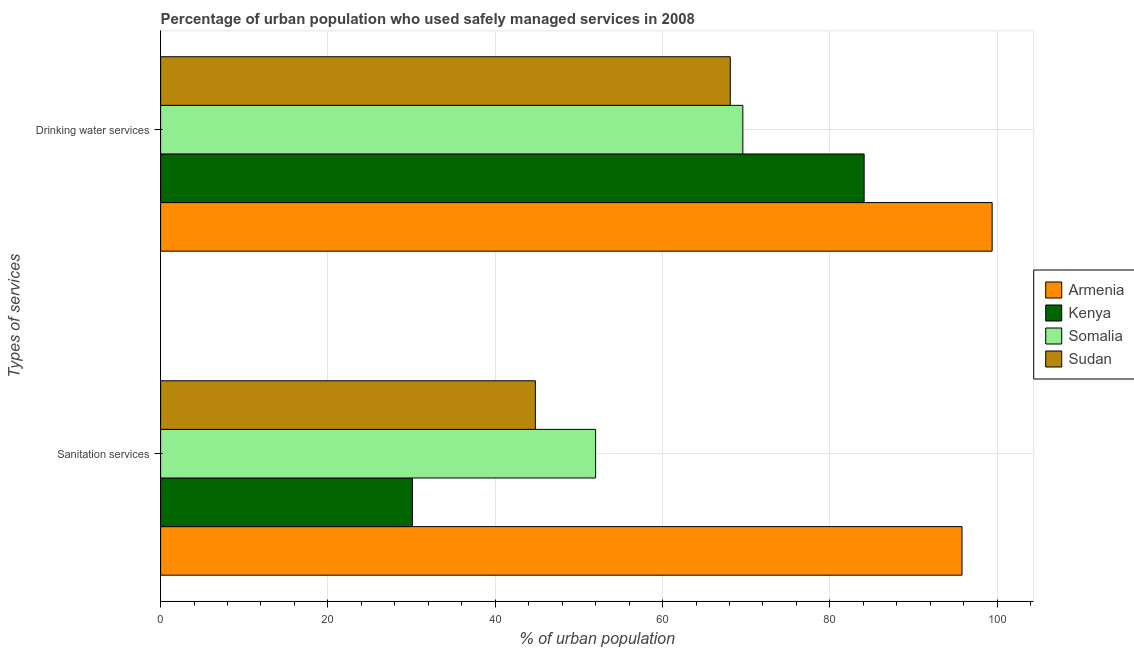How many different coloured bars are there?
Your response must be concise. 4. How many bars are there on the 2nd tick from the top?
Your response must be concise. 4. How many bars are there on the 1st tick from the bottom?
Keep it short and to the point. 4. What is the label of the 1st group of bars from the top?
Offer a terse response. Drinking water services. What is the percentage of urban population who used drinking water services in Sudan?
Make the answer very short. 68.1. Across all countries, what is the maximum percentage of urban population who used drinking water services?
Provide a succinct answer. 99.4. Across all countries, what is the minimum percentage of urban population who used drinking water services?
Provide a succinct answer. 68.1. In which country was the percentage of urban population who used drinking water services maximum?
Your answer should be very brief. Armenia. In which country was the percentage of urban population who used sanitation services minimum?
Make the answer very short. Kenya. What is the total percentage of urban population who used drinking water services in the graph?
Your answer should be compact. 321.2. What is the difference between the percentage of urban population who used sanitation services in Armenia and that in Kenya?
Provide a succinct answer. 65.7. What is the difference between the percentage of urban population who used sanitation services in Kenya and the percentage of urban population who used drinking water services in Sudan?
Ensure brevity in your answer.  -38. What is the average percentage of urban population who used sanitation services per country?
Make the answer very short. 55.67. What is the difference between the percentage of urban population who used drinking water services and percentage of urban population who used sanitation services in Armenia?
Give a very brief answer. 3.6. In how many countries, is the percentage of urban population who used drinking water services greater than 88 %?
Keep it short and to the point. 1. What is the ratio of the percentage of urban population who used drinking water services in Sudan to that in Somalia?
Offer a very short reply. 0.98. In how many countries, is the percentage of urban population who used drinking water services greater than the average percentage of urban population who used drinking water services taken over all countries?
Offer a very short reply. 2. What does the 2nd bar from the top in Drinking water services represents?
Provide a succinct answer. Somalia. What does the 4th bar from the bottom in Drinking water services represents?
Keep it short and to the point. Sudan. How many bars are there?
Provide a succinct answer. 8. What is the difference between two consecutive major ticks on the X-axis?
Your answer should be compact. 20. Are the values on the major ticks of X-axis written in scientific E-notation?
Your answer should be very brief. No. What is the title of the graph?
Your answer should be very brief. Percentage of urban population who used safely managed services in 2008. Does "Qatar" appear as one of the legend labels in the graph?
Keep it short and to the point. No. What is the label or title of the X-axis?
Offer a very short reply. % of urban population. What is the label or title of the Y-axis?
Give a very brief answer. Types of services. What is the % of urban population in Armenia in Sanitation services?
Provide a short and direct response. 95.8. What is the % of urban population of Kenya in Sanitation services?
Your answer should be very brief. 30.1. What is the % of urban population in Sudan in Sanitation services?
Offer a very short reply. 44.8. What is the % of urban population in Armenia in Drinking water services?
Make the answer very short. 99.4. What is the % of urban population in Kenya in Drinking water services?
Provide a succinct answer. 84.1. What is the % of urban population of Somalia in Drinking water services?
Provide a succinct answer. 69.6. What is the % of urban population in Sudan in Drinking water services?
Give a very brief answer. 68.1. Across all Types of services, what is the maximum % of urban population of Armenia?
Provide a short and direct response. 99.4. Across all Types of services, what is the maximum % of urban population in Kenya?
Offer a terse response. 84.1. Across all Types of services, what is the maximum % of urban population of Somalia?
Offer a terse response. 69.6. Across all Types of services, what is the maximum % of urban population of Sudan?
Your answer should be very brief. 68.1. Across all Types of services, what is the minimum % of urban population in Armenia?
Make the answer very short. 95.8. Across all Types of services, what is the minimum % of urban population in Kenya?
Your response must be concise. 30.1. Across all Types of services, what is the minimum % of urban population in Sudan?
Offer a very short reply. 44.8. What is the total % of urban population of Armenia in the graph?
Your answer should be compact. 195.2. What is the total % of urban population in Kenya in the graph?
Ensure brevity in your answer.  114.2. What is the total % of urban population in Somalia in the graph?
Your answer should be compact. 121.6. What is the total % of urban population in Sudan in the graph?
Give a very brief answer. 112.9. What is the difference between the % of urban population in Kenya in Sanitation services and that in Drinking water services?
Give a very brief answer. -54. What is the difference between the % of urban population of Somalia in Sanitation services and that in Drinking water services?
Keep it short and to the point. -17.6. What is the difference between the % of urban population of Sudan in Sanitation services and that in Drinking water services?
Give a very brief answer. -23.3. What is the difference between the % of urban population of Armenia in Sanitation services and the % of urban population of Somalia in Drinking water services?
Keep it short and to the point. 26.2. What is the difference between the % of urban population in Armenia in Sanitation services and the % of urban population in Sudan in Drinking water services?
Ensure brevity in your answer.  27.7. What is the difference between the % of urban population of Kenya in Sanitation services and the % of urban population of Somalia in Drinking water services?
Your answer should be very brief. -39.5. What is the difference between the % of urban population in Kenya in Sanitation services and the % of urban population in Sudan in Drinking water services?
Your answer should be very brief. -38. What is the difference between the % of urban population in Somalia in Sanitation services and the % of urban population in Sudan in Drinking water services?
Give a very brief answer. -16.1. What is the average % of urban population in Armenia per Types of services?
Offer a terse response. 97.6. What is the average % of urban population in Kenya per Types of services?
Make the answer very short. 57.1. What is the average % of urban population in Somalia per Types of services?
Keep it short and to the point. 60.8. What is the average % of urban population in Sudan per Types of services?
Give a very brief answer. 56.45. What is the difference between the % of urban population of Armenia and % of urban population of Kenya in Sanitation services?
Keep it short and to the point. 65.7. What is the difference between the % of urban population of Armenia and % of urban population of Somalia in Sanitation services?
Make the answer very short. 43.8. What is the difference between the % of urban population in Armenia and % of urban population in Sudan in Sanitation services?
Keep it short and to the point. 51. What is the difference between the % of urban population in Kenya and % of urban population in Somalia in Sanitation services?
Your response must be concise. -21.9. What is the difference between the % of urban population of Kenya and % of urban population of Sudan in Sanitation services?
Keep it short and to the point. -14.7. What is the difference between the % of urban population in Armenia and % of urban population in Kenya in Drinking water services?
Your answer should be compact. 15.3. What is the difference between the % of urban population of Armenia and % of urban population of Somalia in Drinking water services?
Ensure brevity in your answer.  29.8. What is the difference between the % of urban population of Armenia and % of urban population of Sudan in Drinking water services?
Your response must be concise. 31.3. What is the difference between the % of urban population in Somalia and % of urban population in Sudan in Drinking water services?
Keep it short and to the point. 1.5. What is the ratio of the % of urban population in Armenia in Sanitation services to that in Drinking water services?
Give a very brief answer. 0.96. What is the ratio of the % of urban population in Kenya in Sanitation services to that in Drinking water services?
Offer a terse response. 0.36. What is the ratio of the % of urban population of Somalia in Sanitation services to that in Drinking water services?
Provide a succinct answer. 0.75. What is the ratio of the % of urban population of Sudan in Sanitation services to that in Drinking water services?
Your answer should be compact. 0.66. What is the difference between the highest and the second highest % of urban population of Armenia?
Give a very brief answer. 3.6. What is the difference between the highest and the second highest % of urban population in Kenya?
Your response must be concise. 54. What is the difference between the highest and the second highest % of urban population in Sudan?
Ensure brevity in your answer.  23.3. What is the difference between the highest and the lowest % of urban population in Armenia?
Your response must be concise. 3.6. What is the difference between the highest and the lowest % of urban population of Kenya?
Your response must be concise. 54. What is the difference between the highest and the lowest % of urban population in Somalia?
Make the answer very short. 17.6. What is the difference between the highest and the lowest % of urban population in Sudan?
Keep it short and to the point. 23.3. 